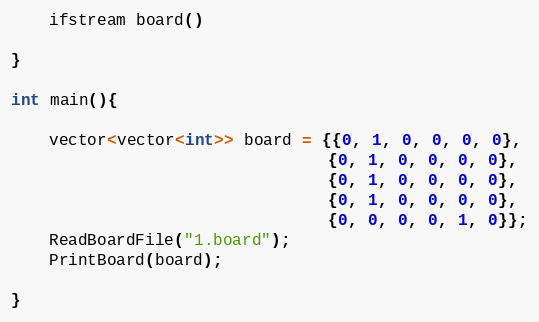<code> <loc_0><loc_0><loc_500><loc_500><_C++_>    ifstream board()

}

int main(){

    vector<vector<int>> board = {{0, 1, 0, 0, 0, 0},
                                 {0, 1, 0, 0, 0, 0},
                                 {0, 1, 0, 0, 0, 0},
                                 {0, 1, 0, 0, 0, 0},
                                 {0, 0, 0, 0, 1, 0}};
    ReadBoardFile("1.board");
    PrintBoard(board);

}</code> 